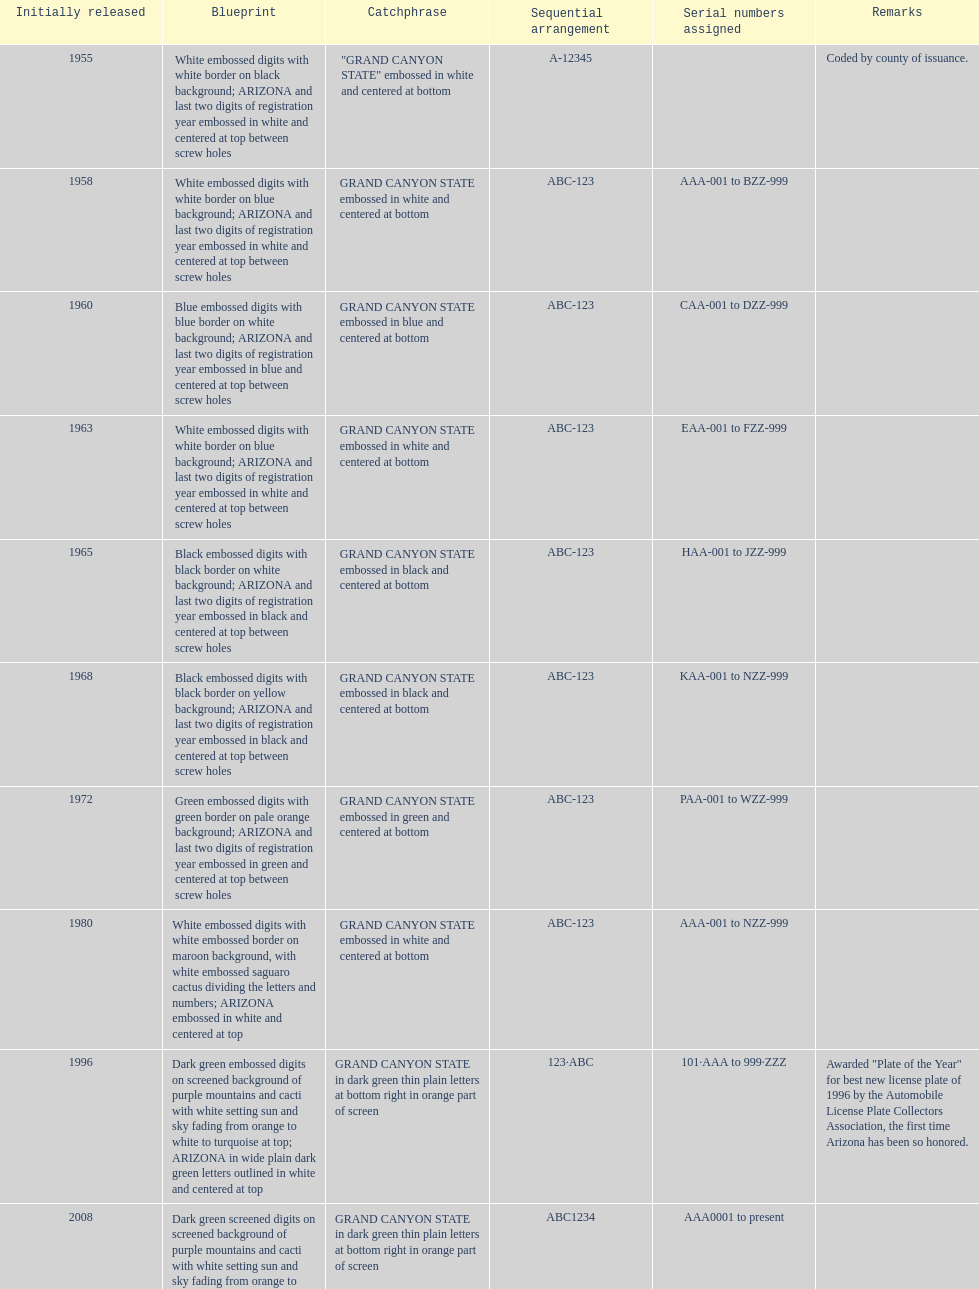What is the average serial format of the arizona license plates? ABC-123. 